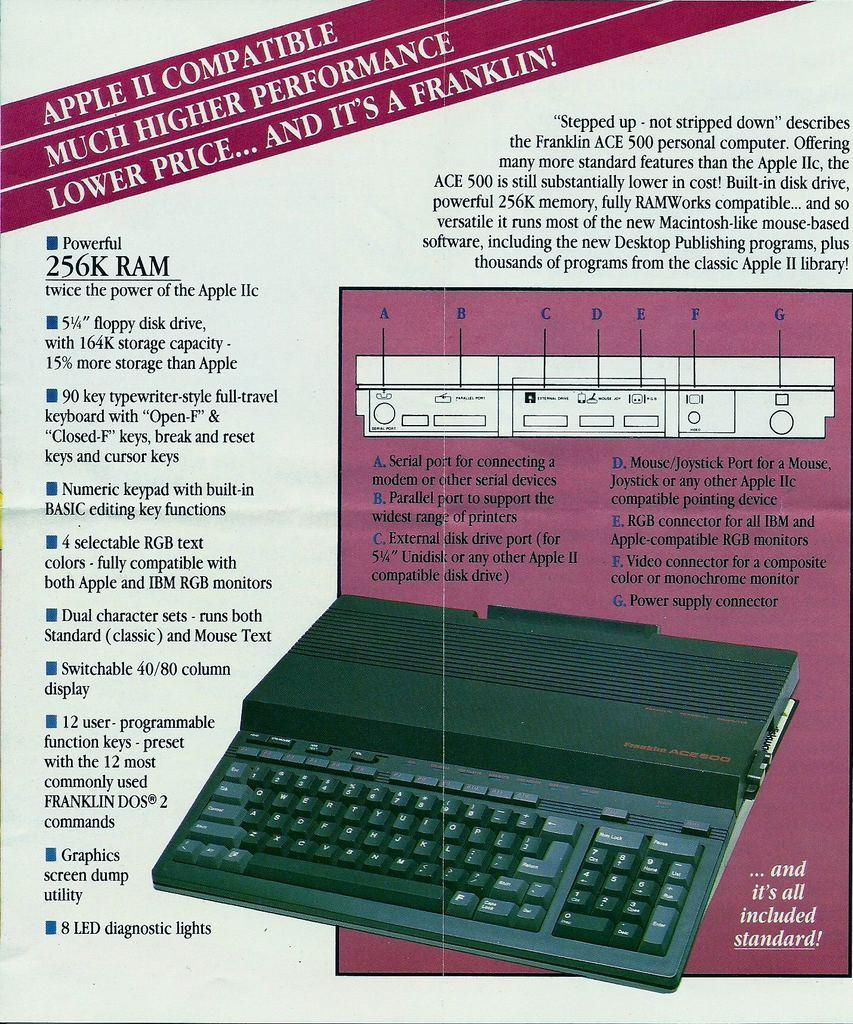<image>
Share a concise interpretation of the image provided. Clear instructions for the Frranklin Ace 500 Personal Computer which is compatible with Apple II. 